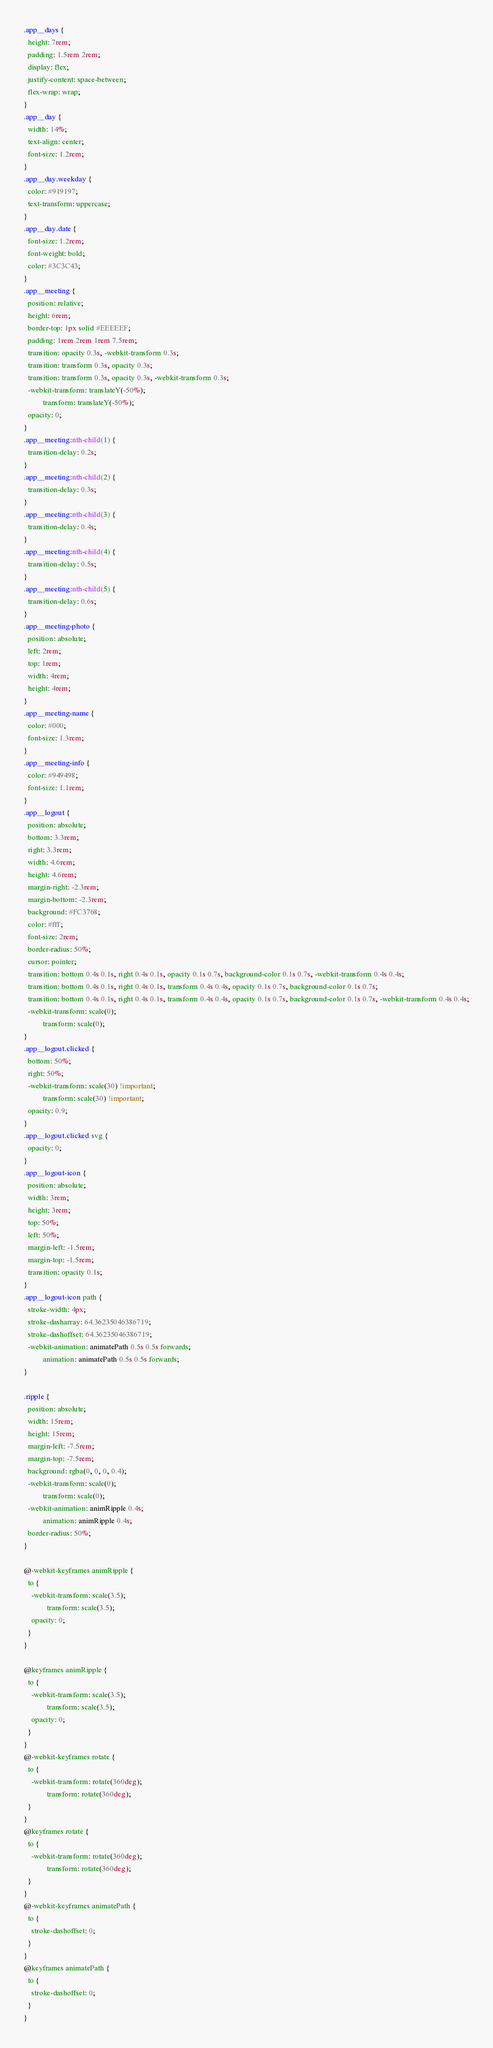Convert code to text. <code><loc_0><loc_0><loc_500><loc_500><_CSS_>.app__days {
  height: 7rem;
  padding: 1.5rem 2rem;
  display: flex;
  justify-content: space-between;
  flex-wrap: wrap;
}
.app__day {
  width: 14%;
  text-align: center;
  font-size: 1.2rem;
}
.app__day.weekday {
  color: #919197;
  text-transform: uppercase;
}
.app__day.date {
  font-size: 1.2rem;
  font-weight: bold;
  color: #3C3C43;
}
.app__meeting {
  position: relative;
  height: 6rem;
  border-top: 1px solid #EEEEEF;
  padding: 1rem 2rem 1rem 7.5rem;
  transition: opacity 0.3s, -webkit-transform 0.3s;
  transition: transform 0.3s, opacity 0.3s;
  transition: transform 0.3s, opacity 0.3s, -webkit-transform 0.3s;
  -webkit-transform: translateY(-50%);
          transform: translateY(-50%);
  opacity: 0;
}
.app__meeting:nth-child(1) {
  transition-delay: 0.2s;
}
.app__meeting:nth-child(2) {
  transition-delay: 0.3s;
}
.app__meeting:nth-child(3) {
  transition-delay: 0.4s;
}
.app__meeting:nth-child(4) {
  transition-delay: 0.5s;
}
.app__meeting:nth-child(5) {
  transition-delay: 0.6s;
}
.app__meeting-photo {
  position: absolute;
  left: 2rem;
  top: 1rem;
  width: 4rem;
  height: 4rem;
}
.app__meeting-name {
  color: #000;
  font-size: 1.3rem;
}
.app__meeting-info {
  color: #949498;
  font-size: 1.1rem;
}
.app__logout {
  position: absolute;
  bottom: 3.3rem;
  right: 3.3rem;
  width: 4.6rem;
  height: 4.6rem;
  margin-right: -2.3rem;
  margin-bottom: -2.3rem;
  background: #FC3768;
  color: #fff;
  font-size: 2rem;
  border-radius: 50%;
  cursor: pointer;
  transition: bottom 0.4s 0.1s, right 0.4s 0.1s, opacity 0.1s 0.7s, background-color 0.1s 0.7s, -webkit-transform 0.4s 0.4s;
  transition: bottom 0.4s 0.1s, right 0.4s 0.1s, transform 0.4s 0.4s, opacity 0.1s 0.7s, background-color 0.1s 0.7s;
  transition: bottom 0.4s 0.1s, right 0.4s 0.1s, transform 0.4s 0.4s, opacity 0.1s 0.7s, background-color 0.1s 0.7s, -webkit-transform 0.4s 0.4s;
  -webkit-transform: scale(0);
          transform: scale(0);
}
.app__logout.clicked {
  bottom: 50%;
  right: 50%;
  -webkit-transform: scale(30) !important;
          transform: scale(30) !important;
  opacity: 0.9;
}
.app__logout.clicked svg {
  opacity: 0;
}
.app__logout-icon {
  position: absolute;
  width: 3rem;
  height: 3rem;
  top: 50%;
  left: 50%;
  margin-left: -1.5rem;
  margin-top: -1.5rem;
  transition: opacity 0.1s;
}
.app__logout-icon path {
  stroke-width: 4px;
  stroke-dasharray: 64.36235046386719;
  stroke-dashoffset: 64.36235046386719;
  -webkit-animation: animatePath 0.5s 0.5s forwards;
          animation: animatePath 0.5s 0.5s forwards;
}

.ripple {
  position: absolute;
  width: 15rem;
  height: 15rem;
  margin-left: -7.5rem;
  margin-top: -7.5rem;
  background: rgba(0, 0, 0, 0.4);
  -webkit-transform: scale(0);
          transform: scale(0);
  -webkit-animation: animRipple 0.4s;
          animation: animRipple 0.4s;
  border-radius: 50%;
}

@-webkit-keyframes animRipple {
  to {
    -webkit-transform: scale(3.5);
            transform: scale(3.5);
    opacity: 0;
  }
}

@keyframes animRipple {
  to {
    -webkit-transform: scale(3.5);
            transform: scale(3.5);
    opacity: 0;
  }
}
@-webkit-keyframes rotate {
  to {
    -webkit-transform: rotate(360deg);
            transform: rotate(360deg);
  }
}
@keyframes rotate {
  to {
    -webkit-transform: rotate(360deg);
            transform: rotate(360deg);
  }
}
@-webkit-keyframes animatePath {
  to {
    stroke-dashoffset: 0;
  }
}
@keyframes animatePath {
  to {
    stroke-dashoffset: 0;
  }
}
</code> 